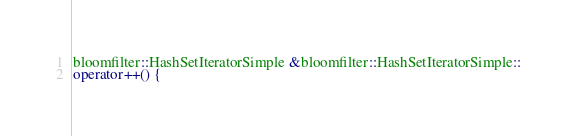<code> <loc_0><loc_0><loc_500><loc_500><_C++_>bloomfilter::HashSetIteratorSimple &bloomfilter::HashSetIteratorSimple::
operator++() {</code> 